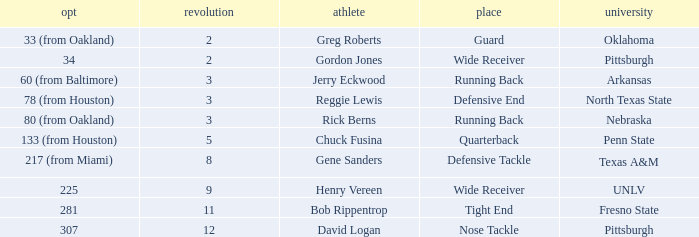In which round was the nose tackle selected? 12.0. 